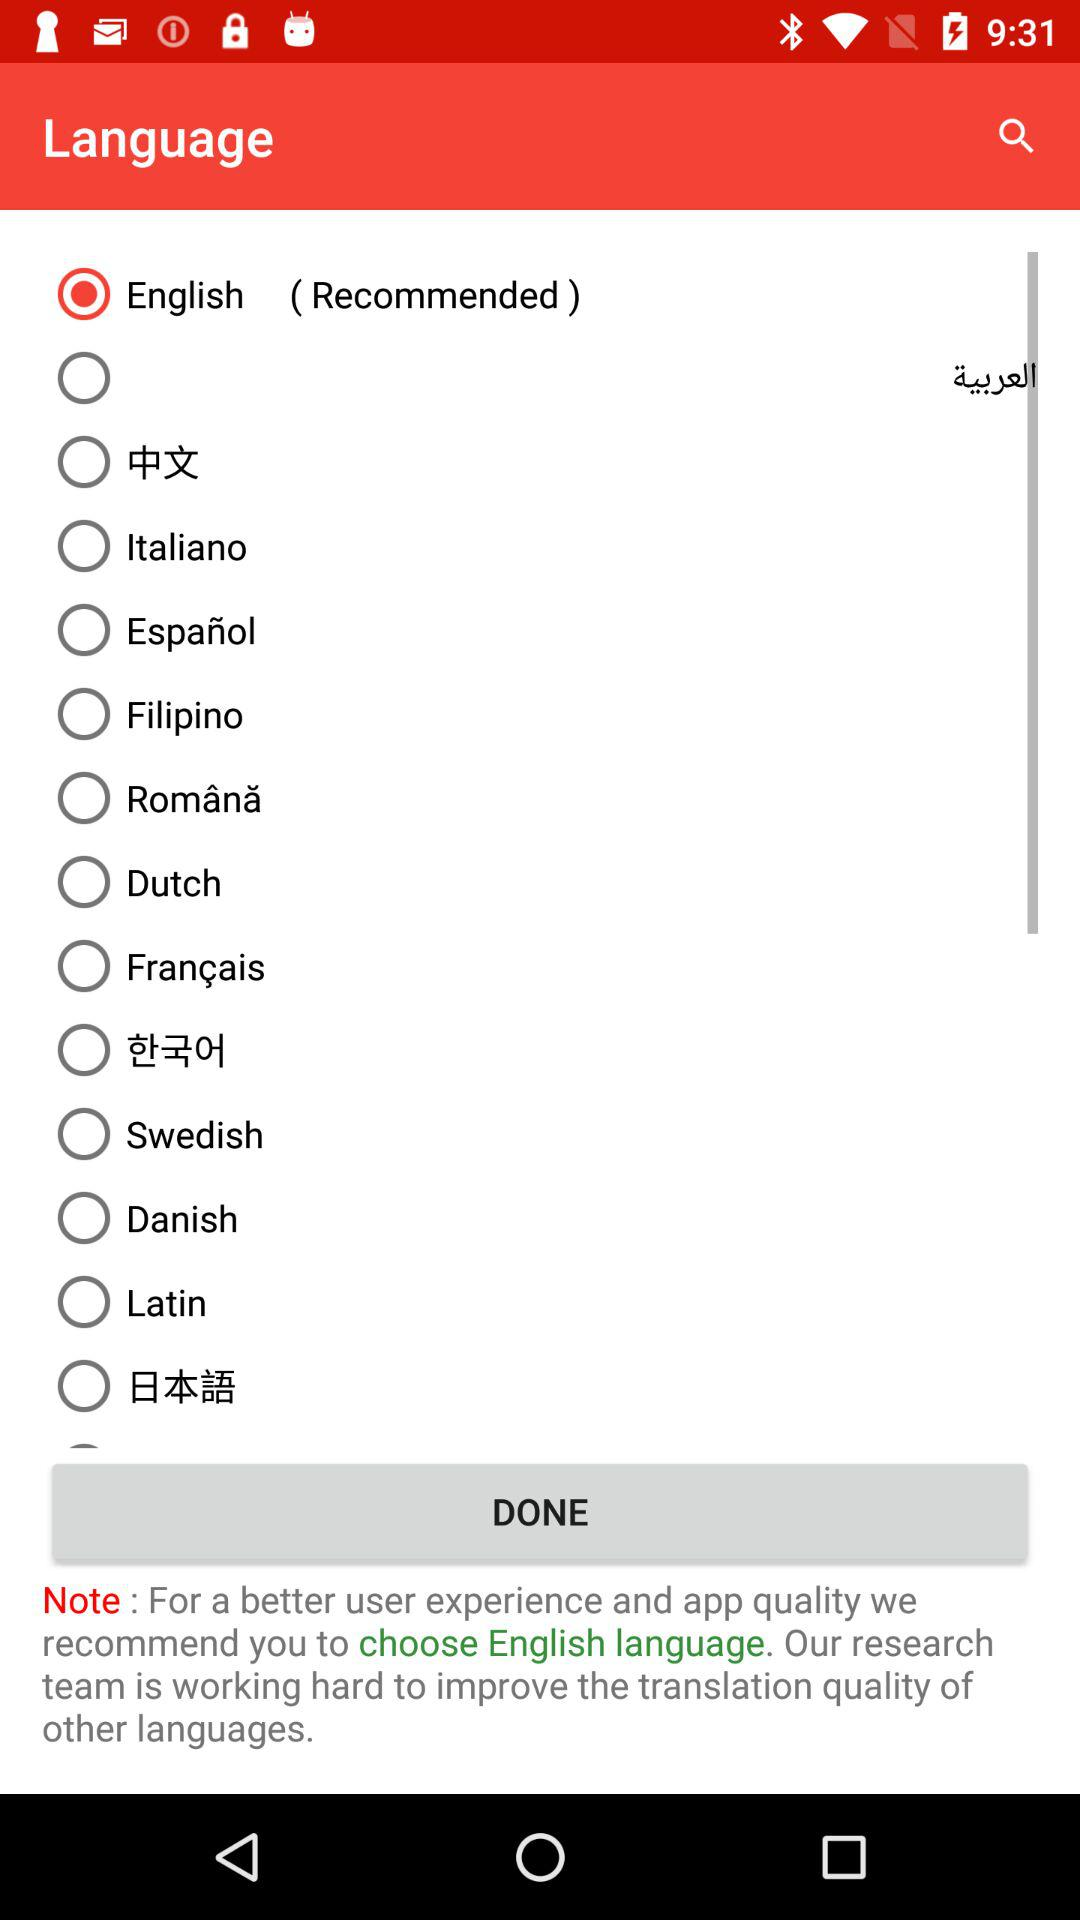What's the selected language? The selected language is "English". 